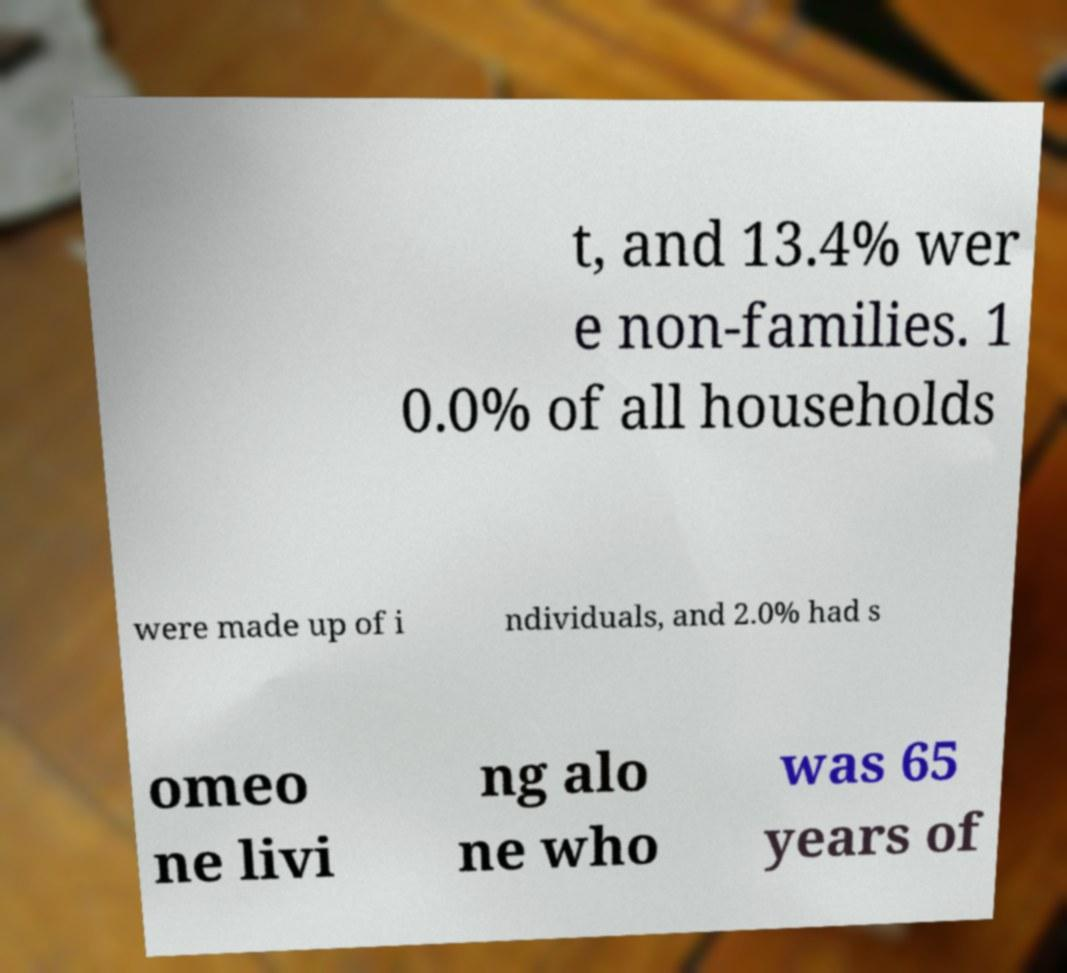I need the written content from this picture converted into text. Can you do that? t, and 13.4% wer e non-families. 1 0.0% of all households were made up of i ndividuals, and 2.0% had s omeo ne livi ng alo ne who was 65 years of 